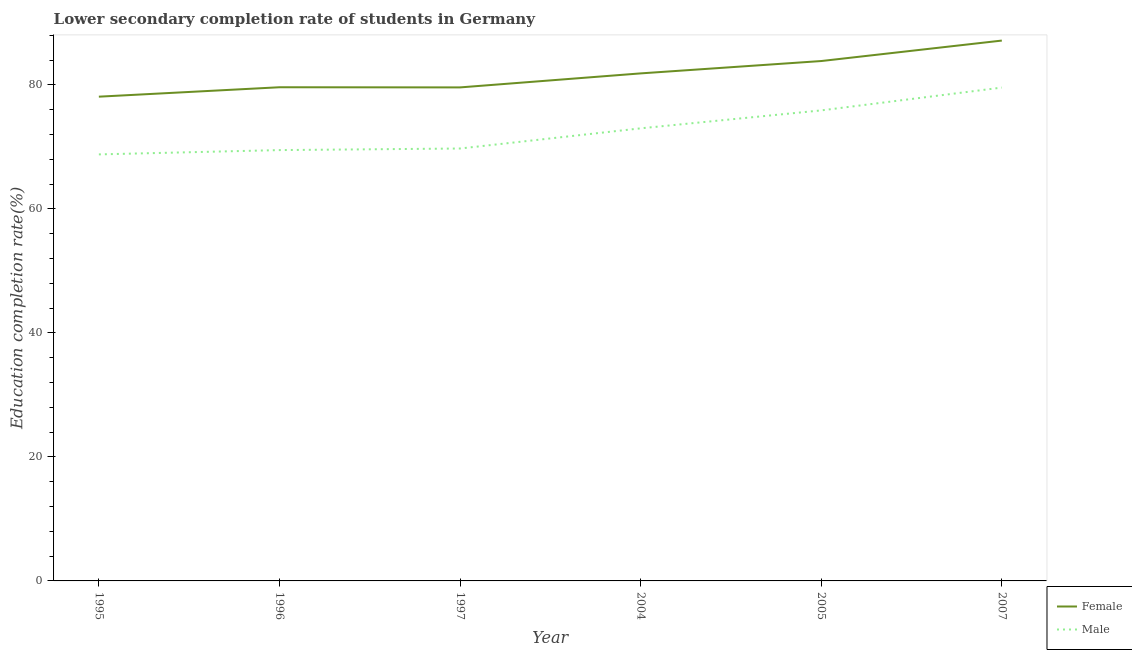How many different coloured lines are there?
Offer a very short reply. 2. Is the number of lines equal to the number of legend labels?
Provide a succinct answer. Yes. What is the education completion rate of female students in 2007?
Ensure brevity in your answer.  87.15. Across all years, what is the maximum education completion rate of male students?
Your response must be concise. 79.57. Across all years, what is the minimum education completion rate of male students?
Offer a very short reply. 68.79. In which year was the education completion rate of male students maximum?
Provide a short and direct response. 2007. What is the total education completion rate of female students in the graph?
Make the answer very short. 490.19. What is the difference between the education completion rate of female students in 1996 and that in 2007?
Your answer should be very brief. -7.53. What is the difference between the education completion rate of male students in 2005 and the education completion rate of female students in 1997?
Provide a succinct answer. -3.71. What is the average education completion rate of male students per year?
Offer a terse response. 72.75. In the year 2007, what is the difference between the education completion rate of female students and education completion rate of male students?
Your response must be concise. 7.58. What is the ratio of the education completion rate of female students in 1996 to that in 2004?
Your response must be concise. 0.97. What is the difference between the highest and the second highest education completion rate of female students?
Give a very brief answer. 3.3. What is the difference between the highest and the lowest education completion rate of male students?
Give a very brief answer. 10.78. In how many years, is the education completion rate of female students greater than the average education completion rate of female students taken over all years?
Offer a very short reply. 3. Is the sum of the education completion rate of male students in 1995 and 2007 greater than the maximum education completion rate of female students across all years?
Ensure brevity in your answer.  Yes. Does the education completion rate of female students monotonically increase over the years?
Make the answer very short. No. How many lines are there?
Make the answer very short. 2. How many years are there in the graph?
Provide a short and direct response. 6. Are the values on the major ticks of Y-axis written in scientific E-notation?
Your response must be concise. No. Does the graph contain any zero values?
Ensure brevity in your answer.  No. Where does the legend appear in the graph?
Keep it short and to the point. Bottom right. What is the title of the graph?
Make the answer very short. Lower secondary completion rate of students in Germany. What is the label or title of the Y-axis?
Provide a short and direct response. Education completion rate(%). What is the Education completion rate(%) in Female in 1995?
Give a very brief answer. 78.11. What is the Education completion rate(%) in Male in 1995?
Provide a short and direct response. 68.79. What is the Education completion rate(%) in Female in 1996?
Keep it short and to the point. 79.62. What is the Education completion rate(%) in Male in 1996?
Keep it short and to the point. 69.49. What is the Education completion rate(%) in Female in 1997?
Your answer should be very brief. 79.6. What is the Education completion rate(%) of Male in 1997?
Your response must be concise. 69.74. What is the Education completion rate(%) in Female in 2004?
Give a very brief answer. 81.86. What is the Education completion rate(%) in Male in 2004?
Your answer should be compact. 73. What is the Education completion rate(%) in Female in 2005?
Your answer should be compact. 83.85. What is the Education completion rate(%) in Male in 2005?
Your response must be concise. 75.89. What is the Education completion rate(%) in Female in 2007?
Provide a succinct answer. 87.15. What is the Education completion rate(%) of Male in 2007?
Ensure brevity in your answer.  79.57. Across all years, what is the maximum Education completion rate(%) of Female?
Your answer should be compact. 87.15. Across all years, what is the maximum Education completion rate(%) of Male?
Ensure brevity in your answer.  79.57. Across all years, what is the minimum Education completion rate(%) of Female?
Keep it short and to the point. 78.11. Across all years, what is the minimum Education completion rate(%) in Male?
Your answer should be very brief. 68.79. What is the total Education completion rate(%) of Female in the graph?
Your answer should be compact. 490.19. What is the total Education completion rate(%) in Male in the graph?
Offer a very short reply. 436.49. What is the difference between the Education completion rate(%) of Female in 1995 and that in 1996?
Offer a very short reply. -1.52. What is the difference between the Education completion rate(%) of Male in 1995 and that in 1996?
Give a very brief answer. -0.69. What is the difference between the Education completion rate(%) in Female in 1995 and that in 1997?
Offer a very short reply. -1.49. What is the difference between the Education completion rate(%) of Male in 1995 and that in 1997?
Offer a very short reply. -0.95. What is the difference between the Education completion rate(%) in Female in 1995 and that in 2004?
Keep it short and to the point. -3.75. What is the difference between the Education completion rate(%) of Male in 1995 and that in 2004?
Your response must be concise. -4.2. What is the difference between the Education completion rate(%) in Female in 1995 and that in 2005?
Keep it short and to the point. -5.75. What is the difference between the Education completion rate(%) in Male in 1995 and that in 2005?
Your answer should be very brief. -7.1. What is the difference between the Education completion rate(%) in Female in 1995 and that in 2007?
Offer a very short reply. -9.05. What is the difference between the Education completion rate(%) in Male in 1995 and that in 2007?
Keep it short and to the point. -10.78. What is the difference between the Education completion rate(%) of Female in 1996 and that in 1997?
Provide a short and direct response. 0.03. What is the difference between the Education completion rate(%) of Male in 1996 and that in 1997?
Offer a very short reply. -0.26. What is the difference between the Education completion rate(%) in Female in 1996 and that in 2004?
Give a very brief answer. -2.23. What is the difference between the Education completion rate(%) of Male in 1996 and that in 2004?
Give a very brief answer. -3.51. What is the difference between the Education completion rate(%) in Female in 1996 and that in 2005?
Provide a short and direct response. -4.23. What is the difference between the Education completion rate(%) in Male in 1996 and that in 2005?
Ensure brevity in your answer.  -6.4. What is the difference between the Education completion rate(%) in Female in 1996 and that in 2007?
Ensure brevity in your answer.  -7.53. What is the difference between the Education completion rate(%) in Male in 1996 and that in 2007?
Offer a very short reply. -10.08. What is the difference between the Education completion rate(%) in Female in 1997 and that in 2004?
Keep it short and to the point. -2.26. What is the difference between the Education completion rate(%) of Male in 1997 and that in 2004?
Offer a terse response. -3.25. What is the difference between the Education completion rate(%) of Female in 1997 and that in 2005?
Your answer should be very brief. -4.25. What is the difference between the Education completion rate(%) in Male in 1997 and that in 2005?
Offer a very short reply. -6.15. What is the difference between the Education completion rate(%) in Female in 1997 and that in 2007?
Your answer should be very brief. -7.55. What is the difference between the Education completion rate(%) in Male in 1997 and that in 2007?
Your answer should be very brief. -9.83. What is the difference between the Education completion rate(%) of Female in 2004 and that in 2005?
Keep it short and to the point. -1.99. What is the difference between the Education completion rate(%) of Male in 2004 and that in 2005?
Your response must be concise. -2.89. What is the difference between the Education completion rate(%) of Female in 2004 and that in 2007?
Your answer should be very brief. -5.29. What is the difference between the Education completion rate(%) of Male in 2004 and that in 2007?
Provide a short and direct response. -6.57. What is the difference between the Education completion rate(%) of Female in 2005 and that in 2007?
Keep it short and to the point. -3.3. What is the difference between the Education completion rate(%) in Male in 2005 and that in 2007?
Your answer should be compact. -3.68. What is the difference between the Education completion rate(%) in Female in 1995 and the Education completion rate(%) in Male in 1996?
Ensure brevity in your answer.  8.62. What is the difference between the Education completion rate(%) of Female in 1995 and the Education completion rate(%) of Male in 1997?
Offer a very short reply. 8.36. What is the difference between the Education completion rate(%) of Female in 1995 and the Education completion rate(%) of Male in 2004?
Provide a succinct answer. 5.11. What is the difference between the Education completion rate(%) in Female in 1995 and the Education completion rate(%) in Male in 2005?
Your response must be concise. 2.21. What is the difference between the Education completion rate(%) of Female in 1995 and the Education completion rate(%) of Male in 2007?
Your answer should be very brief. -1.47. What is the difference between the Education completion rate(%) of Female in 1996 and the Education completion rate(%) of Male in 1997?
Ensure brevity in your answer.  9.88. What is the difference between the Education completion rate(%) of Female in 1996 and the Education completion rate(%) of Male in 2004?
Provide a succinct answer. 6.63. What is the difference between the Education completion rate(%) in Female in 1996 and the Education completion rate(%) in Male in 2005?
Ensure brevity in your answer.  3.73. What is the difference between the Education completion rate(%) of Female in 1996 and the Education completion rate(%) of Male in 2007?
Your response must be concise. 0.05. What is the difference between the Education completion rate(%) in Female in 1997 and the Education completion rate(%) in Male in 2004?
Your answer should be compact. 6.6. What is the difference between the Education completion rate(%) of Female in 1997 and the Education completion rate(%) of Male in 2005?
Provide a succinct answer. 3.71. What is the difference between the Education completion rate(%) of Female in 1997 and the Education completion rate(%) of Male in 2007?
Provide a short and direct response. 0.03. What is the difference between the Education completion rate(%) in Female in 2004 and the Education completion rate(%) in Male in 2005?
Offer a very short reply. 5.97. What is the difference between the Education completion rate(%) in Female in 2004 and the Education completion rate(%) in Male in 2007?
Offer a terse response. 2.29. What is the difference between the Education completion rate(%) of Female in 2005 and the Education completion rate(%) of Male in 2007?
Provide a succinct answer. 4.28. What is the average Education completion rate(%) in Female per year?
Provide a short and direct response. 81.7. What is the average Education completion rate(%) in Male per year?
Make the answer very short. 72.75. In the year 1995, what is the difference between the Education completion rate(%) in Female and Education completion rate(%) in Male?
Keep it short and to the point. 9.31. In the year 1996, what is the difference between the Education completion rate(%) of Female and Education completion rate(%) of Male?
Your response must be concise. 10.14. In the year 1997, what is the difference between the Education completion rate(%) in Female and Education completion rate(%) in Male?
Offer a very short reply. 9.86. In the year 2004, what is the difference between the Education completion rate(%) in Female and Education completion rate(%) in Male?
Your answer should be compact. 8.86. In the year 2005, what is the difference between the Education completion rate(%) of Female and Education completion rate(%) of Male?
Your answer should be very brief. 7.96. In the year 2007, what is the difference between the Education completion rate(%) of Female and Education completion rate(%) of Male?
Provide a succinct answer. 7.58. What is the ratio of the Education completion rate(%) of Female in 1995 to that in 1996?
Ensure brevity in your answer.  0.98. What is the ratio of the Education completion rate(%) in Female in 1995 to that in 1997?
Ensure brevity in your answer.  0.98. What is the ratio of the Education completion rate(%) in Male in 1995 to that in 1997?
Make the answer very short. 0.99. What is the ratio of the Education completion rate(%) of Female in 1995 to that in 2004?
Offer a terse response. 0.95. What is the ratio of the Education completion rate(%) in Male in 1995 to that in 2004?
Keep it short and to the point. 0.94. What is the ratio of the Education completion rate(%) of Female in 1995 to that in 2005?
Provide a succinct answer. 0.93. What is the ratio of the Education completion rate(%) in Male in 1995 to that in 2005?
Provide a short and direct response. 0.91. What is the ratio of the Education completion rate(%) of Female in 1995 to that in 2007?
Ensure brevity in your answer.  0.9. What is the ratio of the Education completion rate(%) of Male in 1995 to that in 2007?
Offer a terse response. 0.86. What is the ratio of the Education completion rate(%) in Female in 1996 to that in 1997?
Ensure brevity in your answer.  1. What is the ratio of the Education completion rate(%) in Male in 1996 to that in 1997?
Provide a short and direct response. 1. What is the ratio of the Education completion rate(%) in Female in 1996 to that in 2004?
Keep it short and to the point. 0.97. What is the ratio of the Education completion rate(%) in Male in 1996 to that in 2004?
Keep it short and to the point. 0.95. What is the ratio of the Education completion rate(%) in Female in 1996 to that in 2005?
Give a very brief answer. 0.95. What is the ratio of the Education completion rate(%) in Male in 1996 to that in 2005?
Offer a very short reply. 0.92. What is the ratio of the Education completion rate(%) in Female in 1996 to that in 2007?
Ensure brevity in your answer.  0.91. What is the ratio of the Education completion rate(%) in Male in 1996 to that in 2007?
Offer a very short reply. 0.87. What is the ratio of the Education completion rate(%) of Female in 1997 to that in 2004?
Your answer should be compact. 0.97. What is the ratio of the Education completion rate(%) of Male in 1997 to that in 2004?
Make the answer very short. 0.96. What is the ratio of the Education completion rate(%) in Female in 1997 to that in 2005?
Ensure brevity in your answer.  0.95. What is the ratio of the Education completion rate(%) of Male in 1997 to that in 2005?
Keep it short and to the point. 0.92. What is the ratio of the Education completion rate(%) in Female in 1997 to that in 2007?
Give a very brief answer. 0.91. What is the ratio of the Education completion rate(%) of Male in 1997 to that in 2007?
Your response must be concise. 0.88. What is the ratio of the Education completion rate(%) of Female in 2004 to that in 2005?
Your answer should be very brief. 0.98. What is the ratio of the Education completion rate(%) in Male in 2004 to that in 2005?
Ensure brevity in your answer.  0.96. What is the ratio of the Education completion rate(%) of Female in 2004 to that in 2007?
Keep it short and to the point. 0.94. What is the ratio of the Education completion rate(%) of Male in 2004 to that in 2007?
Keep it short and to the point. 0.92. What is the ratio of the Education completion rate(%) of Female in 2005 to that in 2007?
Provide a short and direct response. 0.96. What is the ratio of the Education completion rate(%) in Male in 2005 to that in 2007?
Ensure brevity in your answer.  0.95. What is the difference between the highest and the second highest Education completion rate(%) in Female?
Your response must be concise. 3.3. What is the difference between the highest and the second highest Education completion rate(%) of Male?
Ensure brevity in your answer.  3.68. What is the difference between the highest and the lowest Education completion rate(%) in Female?
Give a very brief answer. 9.05. What is the difference between the highest and the lowest Education completion rate(%) of Male?
Make the answer very short. 10.78. 